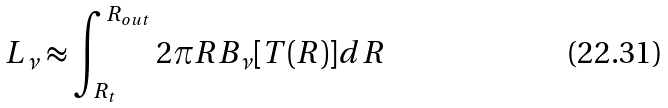Convert formula to latex. <formula><loc_0><loc_0><loc_500><loc_500>L _ { \nu } \approx \int _ { R _ { t } } ^ { R _ { o u t } } 2 \pi R B _ { \nu } [ T ( R ) ] d R</formula> 